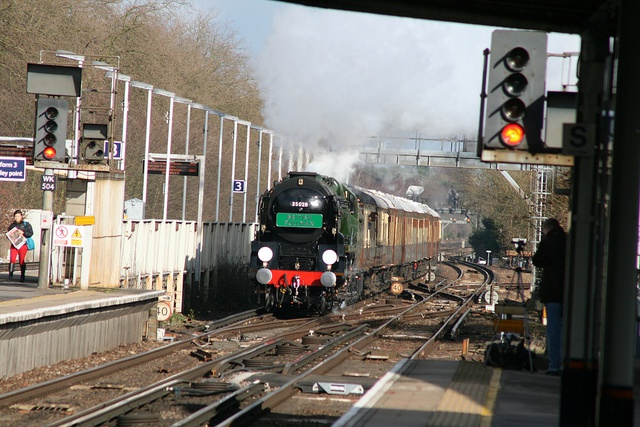Describe the objects in this image and their specific colors. I can see train in gray, black, and darkgray tones, traffic light in gray and black tones, people in gray, black, and darkgray tones, traffic light in gray, black, and maroon tones, and people in gray, black, ivory, and lightpink tones in this image. 